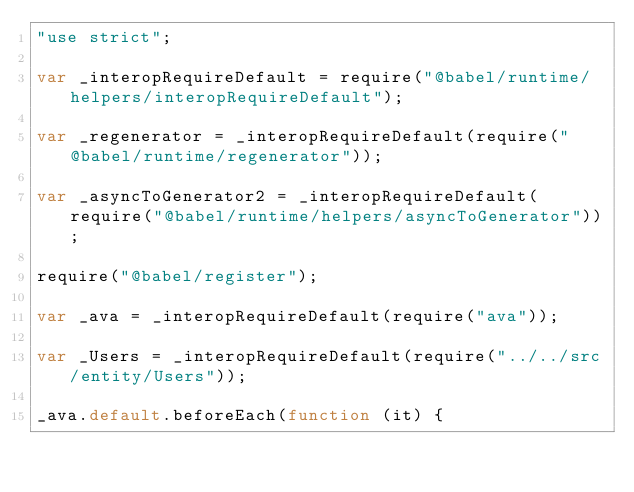Convert code to text. <code><loc_0><loc_0><loc_500><loc_500><_JavaScript_>"use strict";

var _interopRequireDefault = require("@babel/runtime/helpers/interopRequireDefault");

var _regenerator = _interopRequireDefault(require("@babel/runtime/regenerator"));

var _asyncToGenerator2 = _interopRequireDefault(require("@babel/runtime/helpers/asyncToGenerator"));

require("@babel/register");

var _ava = _interopRequireDefault(require("ava"));

var _Users = _interopRequireDefault(require("../../src/entity/Users"));

_ava.default.beforeEach(function (it) {</code> 